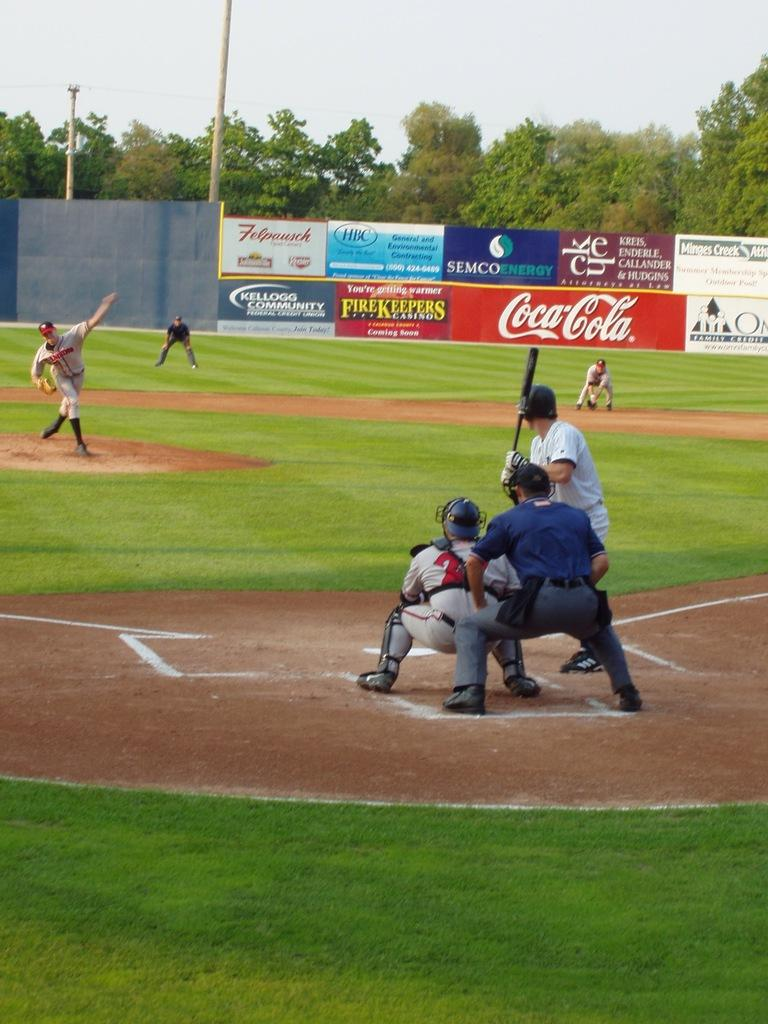<image>
Share a concise interpretation of the image provided. a coca cola ad in the outfield of a game 